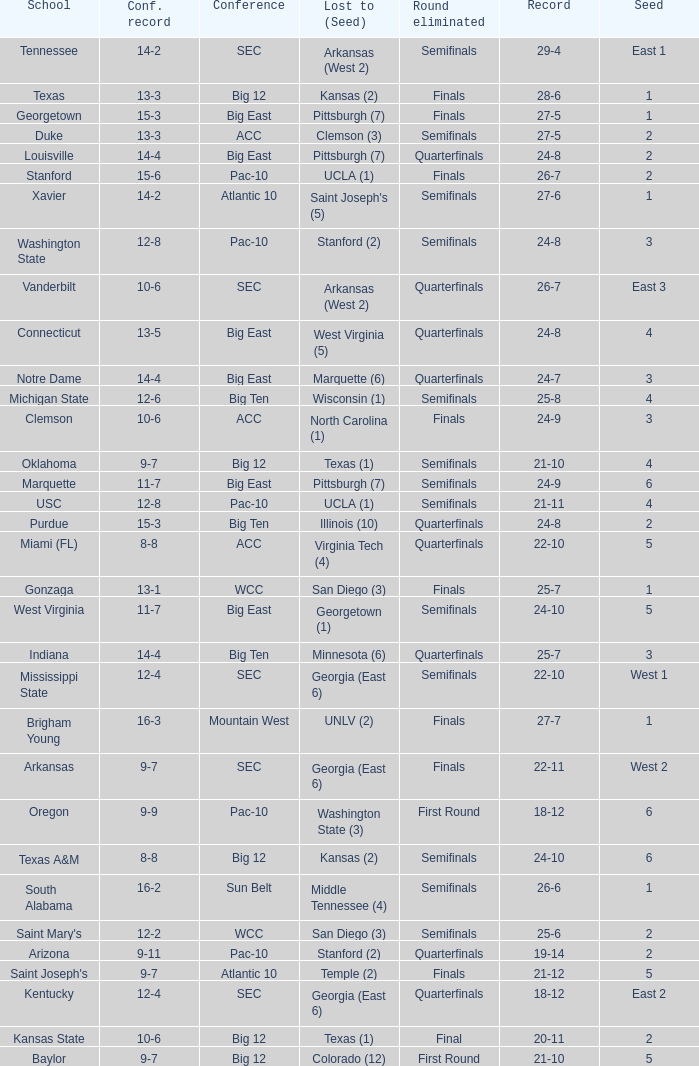Name the conference record where seed is 3 and record is 24-9 10-6. 